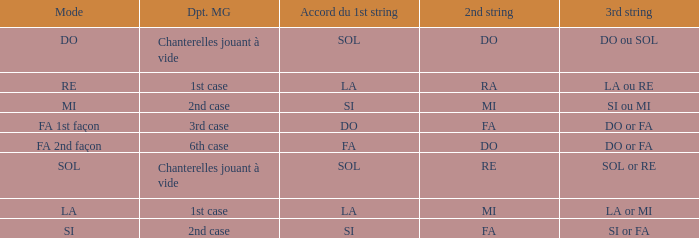For the 2nd string of Ra what is the Depart de la main gauche? 1st case. 